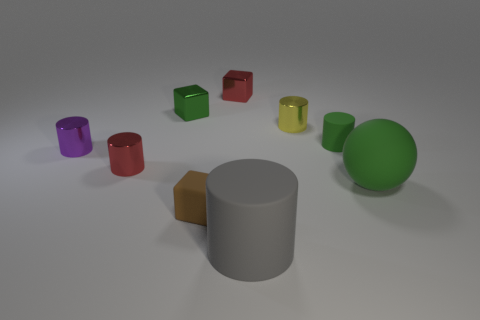Subtract all brown cylinders. Subtract all red balls. How many cylinders are left? 5 Subtract all cylinders. How many objects are left? 4 Add 7 big red balls. How many big red balls exist? 7 Subtract 0 gray blocks. How many objects are left? 9 Subtract all purple cylinders. Subtract all large rubber things. How many objects are left? 6 Add 6 tiny yellow metal things. How many tiny yellow metal things are left? 7 